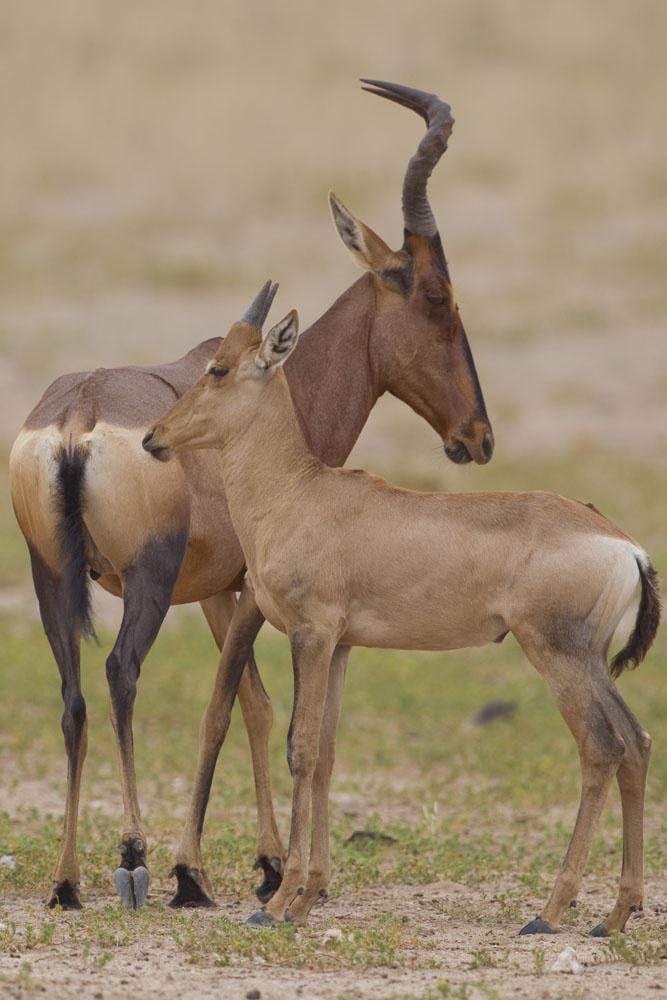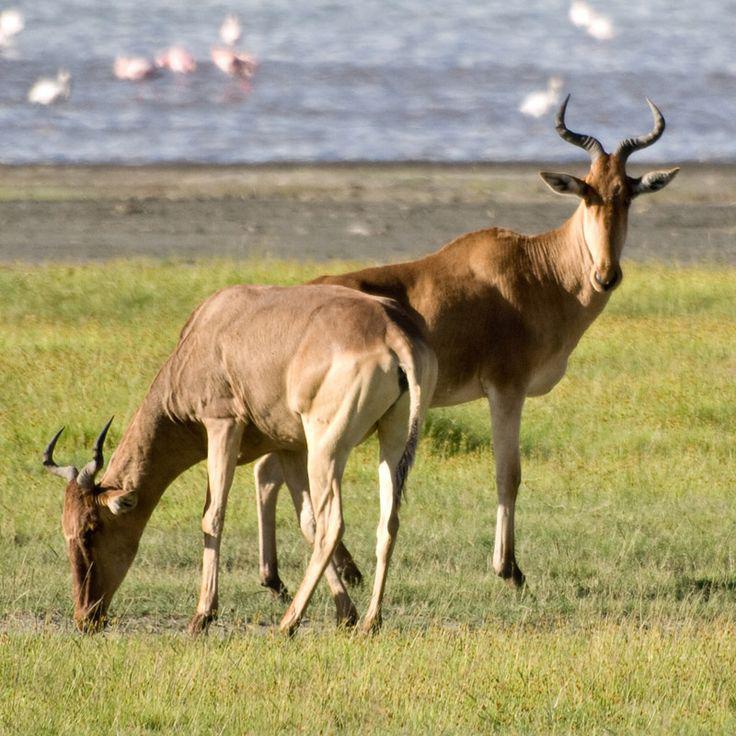The first image is the image on the left, the second image is the image on the right. Assess this claim about the two images: "There are less than four animals with horns visible.". Correct or not? Answer yes or no. No. The first image is the image on the left, the second image is the image on the right. For the images displayed, is the sentence "Two of the animals are standing close together with heads high facing opposite directions." factually correct? Answer yes or no. Yes. 